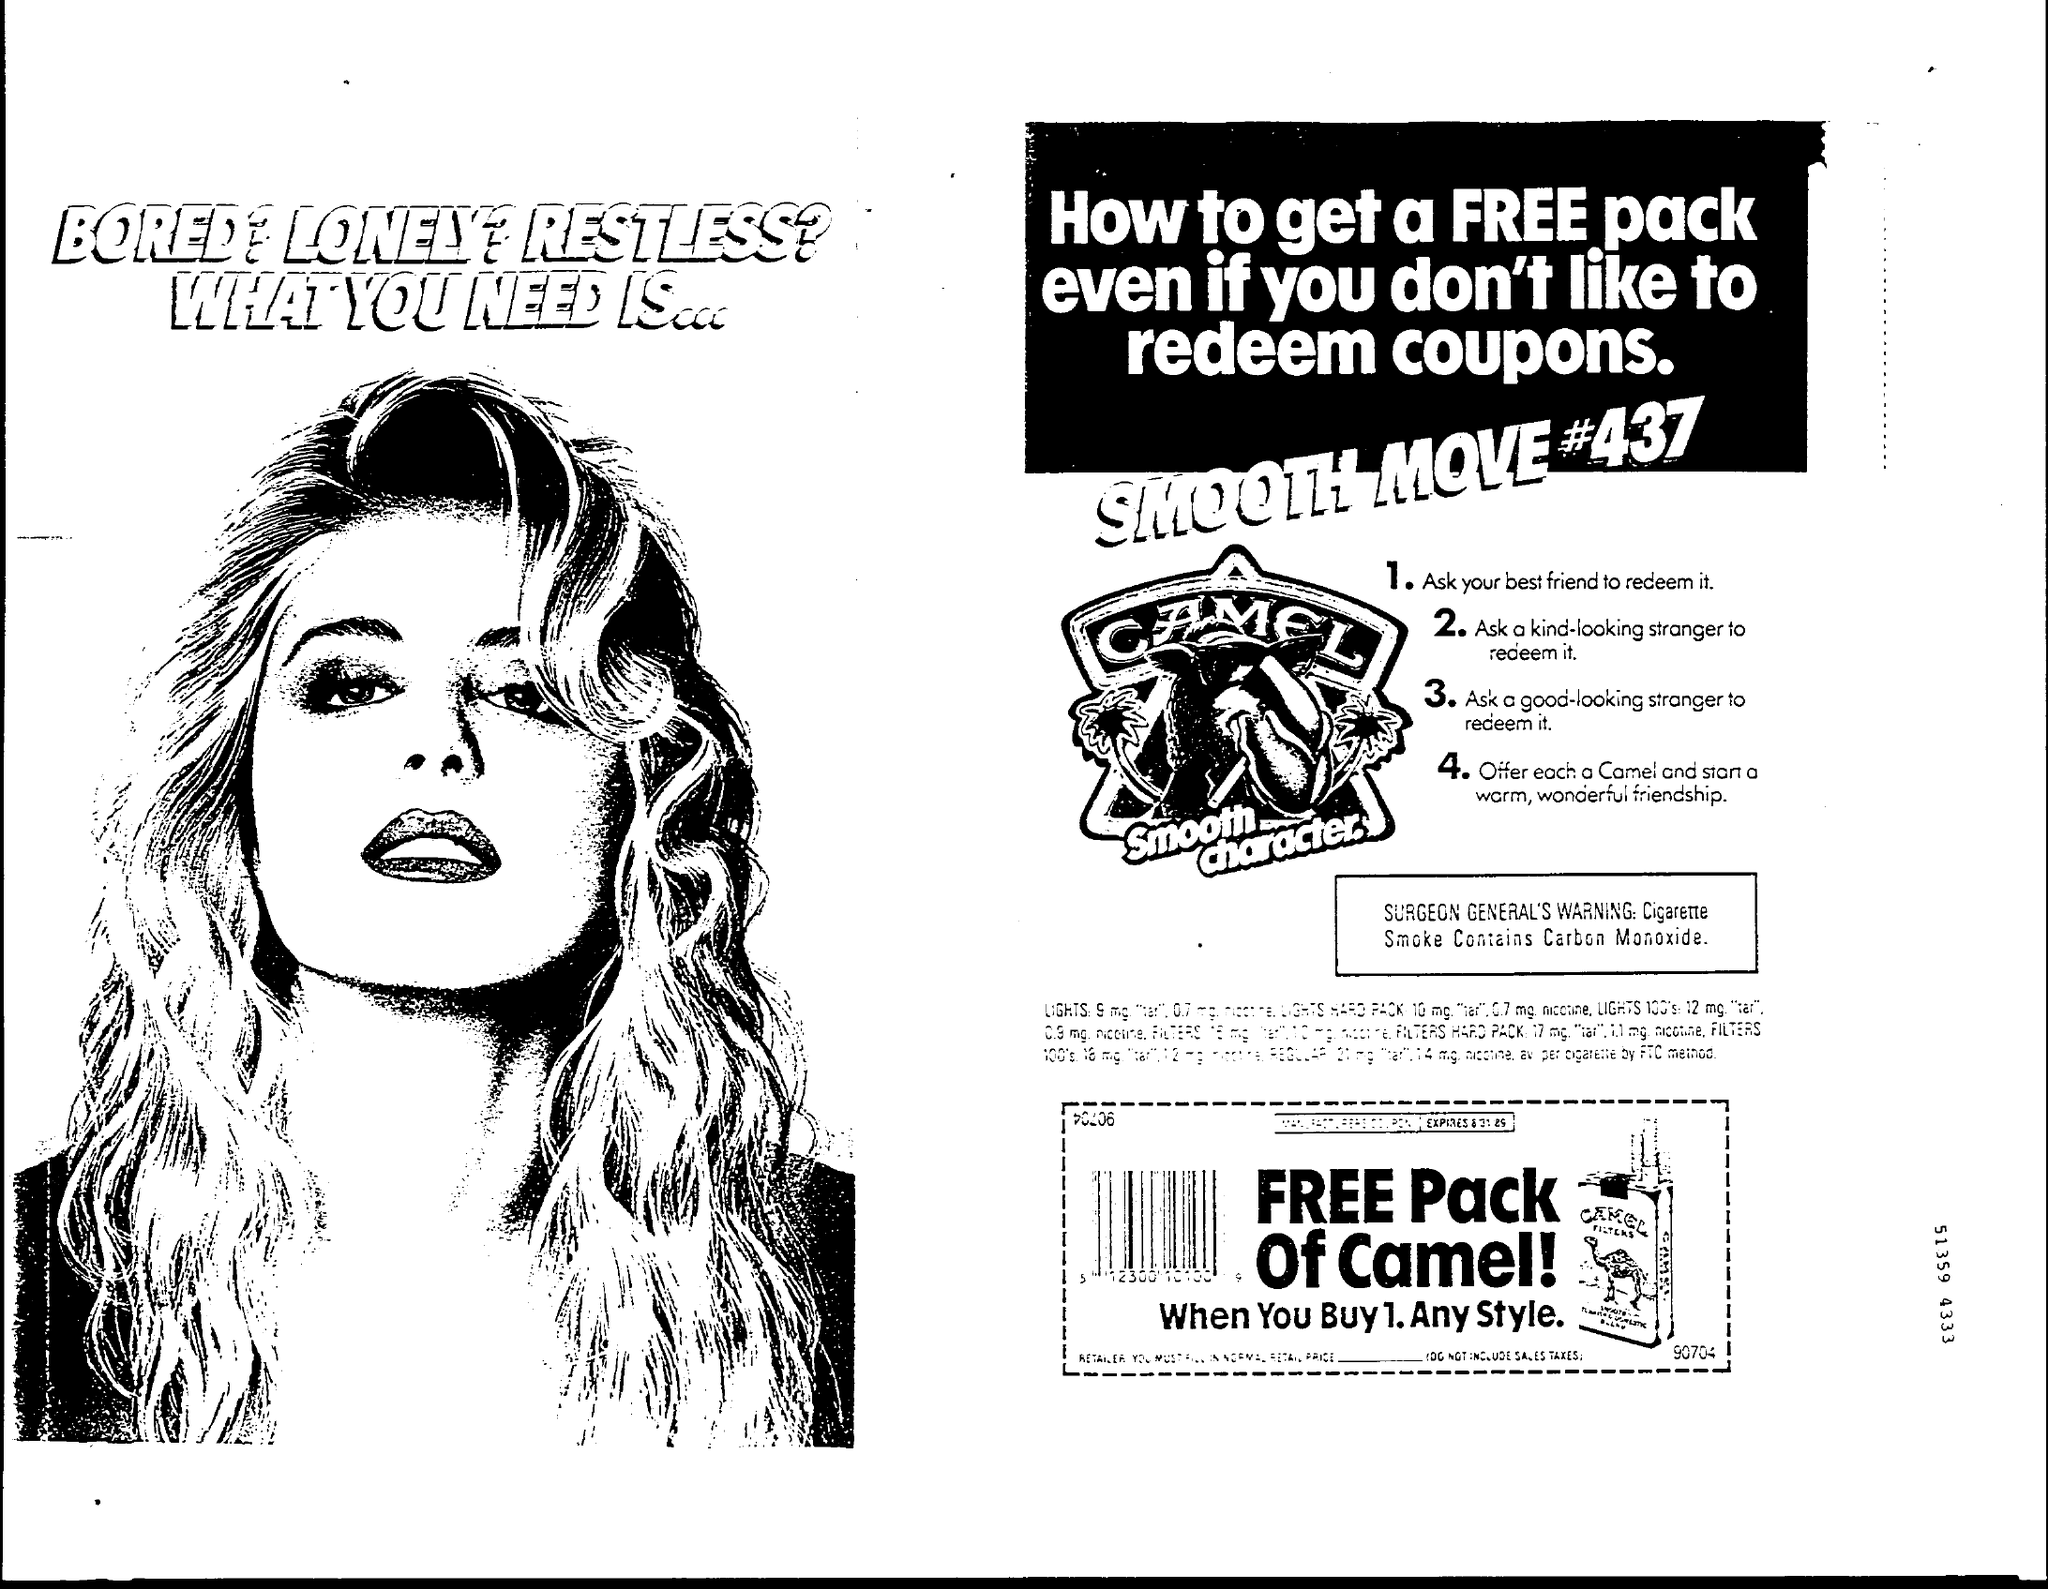Point out several critical features in this image. The Surgeon General's warning states that cigarette smoke contains carbon monoxide, which can negatively impact the body. CAMEL is the brand that is mentioned. 